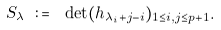Convert formula to latex. <formula><loc_0><loc_0><loc_500><loc_500>S _ { \lambda } \ \colon = \ \det ( h _ { \lambda _ { i } + j - i } ) _ { 1 \leq i , j \leq p + 1 } .</formula> 